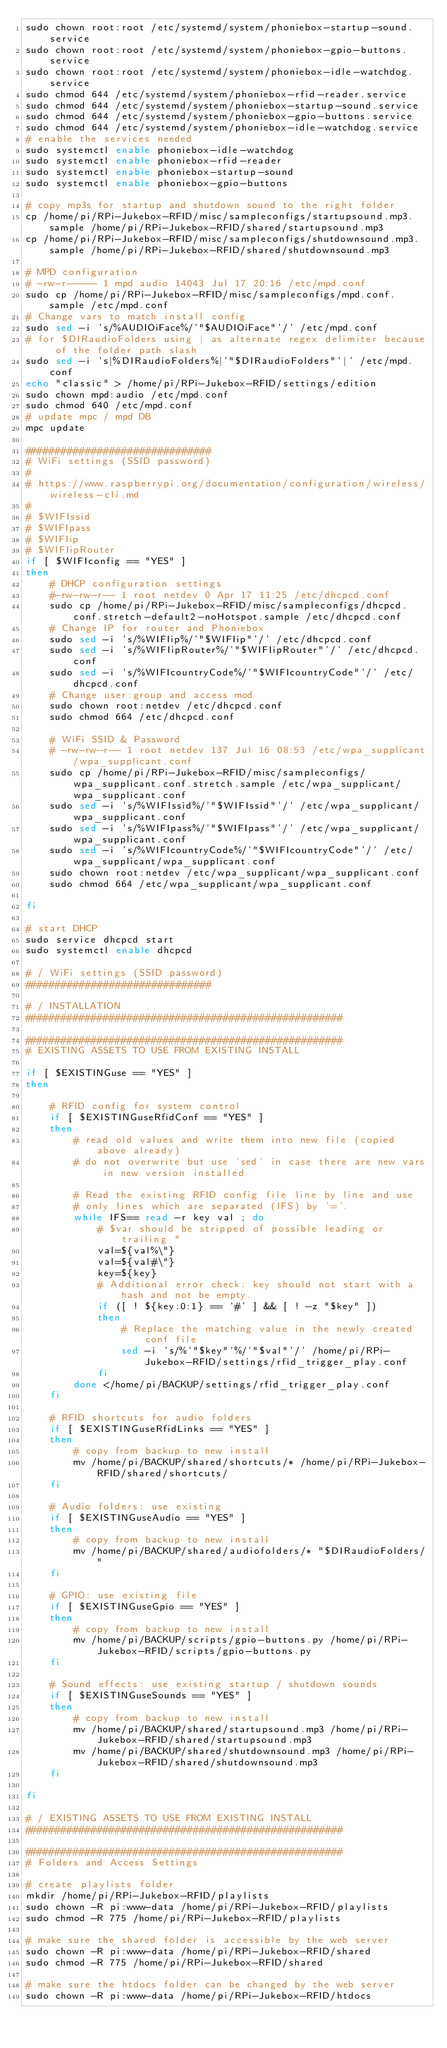<code> <loc_0><loc_0><loc_500><loc_500><_Bash_>sudo chown root:root /etc/systemd/system/phoniebox-startup-sound.service
sudo chown root:root /etc/systemd/system/phoniebox-gpio-buttons.service
sudo chown root:root /etc/systemd/system/phoniebox-idle-watchdog.service
sudo chmod 644 /etc/systemd/system/phoniebox-rfid-reader.service
sudo chmod 644 /etc/systemd/system/phoniebox-startup-sound.service
sudo chmod 644 /etc/systemd/system/phoniebox-gpio-buttons.service
sudo chmod 644 /etc/systemd/system/phoniebox-idle-watchdog.service
# enable the services needed
sudo systemctl enable phoniebox-idle-watchdog
sudo systemctl enable phoniebox-rfid-reader
sudo systemctl enable phoniebox-startup-sound
sudo systemctl enable phoniebox-gpio-buttons

# copy mp3s for startup and shutdown sound to the right folder
cp /home/pi/RPi-Jukebox-RFID/misc/sampleconfigs/startupsound.mp3.sample /home/pi/RPi-Jukebox-RFID/shared/startupsound.mp3
cp /home/pi/RPi-Jukebox-RFID/misc/sampleconfigs/shutdownsound.mp3.sample /home/pi/RPi-Jukebox-RFID/shared/shutdownsound.mp3

# MPD configuration
# -rw-r----- 1 mpd audio 14043 Jul 17 20:16 /etc/mpd.conf
sudo cp /home/pi/RPi-Jukebox-RFID/misc/sampleconfigs/mpd.conf.sample /etc/mpd.conf
# Change vars to match install config
sudo sed -i 's/%AUDIOiFace%/'"$AUDIOiFace"'/' /etc/mpd.conf
# for $DIRaudioFolders using | as alternate regex delimiter because of the folder path slash 
sudo sed -i 's|%DIRaudioFolders%|'"$DIRaudioFolders"'|' /etc/mpd.conf
echo "classic" > /home/pi/RPi-Jukebox-RFID/settings/edition
sudo chown mpd:audio /etc/mpd.conf
sudo chmod 640 /etc/mpd.conf
# update mpc / mpd DB
mpc update

###############################
# WiFi settings (SSID password)
#
# https://www.raspberrypi.org/documentation/configuration/wireless/wireless-cli.md
# 
# $WIFIssid
# $WIFIpass
# $WIFIip
# $WIFIipRouter
if [ $WIFIconfig == "YES" ]
then
    # DHCP configuration settings
    #-rw-rw-r-- 1 root netdev 0 Apr 17 11:25 /etc/dhcpcd.conf
    sudo cp /home/pi/RPi-Jukebox-RFID/misc/sampleconfigs/dhcpcd.conf.stretch-default2-noHotspot.sample /etc/dhcpcd.conf
    # Change IP for router and Phoniebox
    sudo sed -i 's/%WIFIip%/'"$WIFIip"'/' /etc/dhcpcd.conf
    sudo sed -i 's/%WIFIipRouter%/'"$WIFIipRouter"'/' /etc/dhcpcd.conf
    sudo sed -i 's/%WIFIcountryCode%/'"$WIFIcountryCode"'/' /etc/dhcpcd.conf
    # Change user:group and access mod
    sudo chown root:netdev /etc/dhcpcd.conf
    sudo chmod 664 /etc/dhcpcd.conf
    
    # WiFi SSID & Password
    # -rw-rw-r-- 1 root netdev 137 Jul 16 08:53 /etc/wpa_supplicant/wpa_supplicant.conf
    sudo cp /home/pi/RPi-Jukebox-RFID/misc/sampleconfigs/wpa_supplicant.conf.stretch.sample /etc/wpa_supplicant/wpa_supplicant.conf
    sudo sed -i 's/%WIFIssid%/'"$WIFIssid"'/' /etc/wpa_supplicant/wpa_supplicant.conf
    sudo sed -i 's/%WIFIpass%/'"$WIFIpass"'/' /etc/wpa_supplicant/wpa_supplicant.conf
    sudo sed -i 's/%WIFIcountryCode%/'"$WIFIcountryCode"'/' /etc/wpa_supplicant/wpa_supplicant.conf
    sudo chown root:netdev /etc/wpa_supplicant/wpa_supplicant.conf
    sudo chmod 664 /etc/wpa_supplicant/wpa_supplicant.conf

fi

# start DHCP
sudo service dhcpcd start
sudo systemctl enable dhcpcd

# / WiFi settings (SSID password)
###############################

# / INSTALLATION
##################################################### 

##################################################### 
# EXISTING ASSETS TO USE FROM EXISTING INSTALL

if [ $EXISTINGuse == "YES" ]
then
    
    # RFID config for system control
    if [ $EXISTINGuseRfidConf == "YES" ]
    then
        # read old values and write them into new file (copied above already)
        # do not overwrite but use 'sed' in case there are new vars in new version installed
        
        # Read the existing RFID config file line by line and use
        # only lines which are separated (IFS) by '='.
        while IFS== read -r key val ; do
            # $var should be stripped of possible leading or trailing "
            val=${val%\"}
            val=${val#\"} 
            key=${key}
            # Additional error check: key should not start with a hash and not be empty.
            if ([ ! ${key:0:1} == '#' ] && [ ! -z "$key" ])
            then
                # Replace the matching value in the newly created conf file
                sed -i 's/%'"$key"'%/'"$val"'/' /home/pi/RPi-Jukebox-RFID/settings/rfid_trigger_play.conf
            fi
        done </home/pi/BACKUP/settings/rfid_trigger_play.conf
    fi
    
    # RFID shortcuts for audio folders
    if [ $EXISTINGuseRfidLinks == "YES" ]
    then
        # copy from backup to new install
        mv /home/pi/BACKUP/shared/shortcuts/* /home/pi/RPi-Jukebox-RFID/shared/shortcuts/
    fi
    
    # Audio folders: use existing
    if [ $EXISTINGuseAudio == "YES" ]
    then
        # copy from backup to new install
        mv /home/pi/BACKUP/shared/audiofolders/* "$DIRaudioFolders/"
    fi
    
    # GPIO: use existing file
    if [ $EXISTINGuseGpio == "YES" ]
    then
        # copy from backup to new install
        mv /home/pi/BACKUP/scripts/gpio-buttons.py /home/pi/RPi-Jukebox-RFID/scripts/gpio-buttons.py
    fi
    
    # Sound effects: use existing startup / shutdown sounds
    if [ $EXISTINGuseSounds == "YES" ]
    then
        # copy from backup to new install
        mv /home/pi/BACKUP/shared/startupsound.mp3 /home/pi/RPi-Jukebox-RFID/shared/startupsound.mp3
        mv /home/pi/BACKUP/shared/shutdownsound.mp3 /home/pi/RPi-Jukebox-RFID/shared/shutdownsound.mp3
    fi

fi

# / EXISTING ASSETS TO USE FROM EXISTING INSTALL
##################################################### 

##################################################### 
# Folders and Access Settings

# create playlists folder
mkdir /home/pi/RPi-Jukebox-RFID/playlists
sudo chown -R pi:www-data /home/pi/RPi-Jukebox-RFID/playlists
sudo chmod -R 775 /home/pi/RPi-Jukebox-RFID/playlists

# make sure the shared folder is accessible by the web server
sudo chown -R pi:www-data /home/pi/RPi-Jukebox-RFID/shared
sudo chmod -R 775 /home/pi/RPi-Jukebox-RFID/shared

# make sure the htdocs folder can be changed by the web server
sudo chown -R pi:www-data /home/pi/RPi-Jukebox-RFID/htdocs</code> 